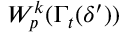Convert formula to latex. <formula><loc_0><loc_0><loc_500><loc_500>W _ { p } ^ { k } ( \Gamma _ { t } ( \delta ^ { \prime } ) )</formula> 